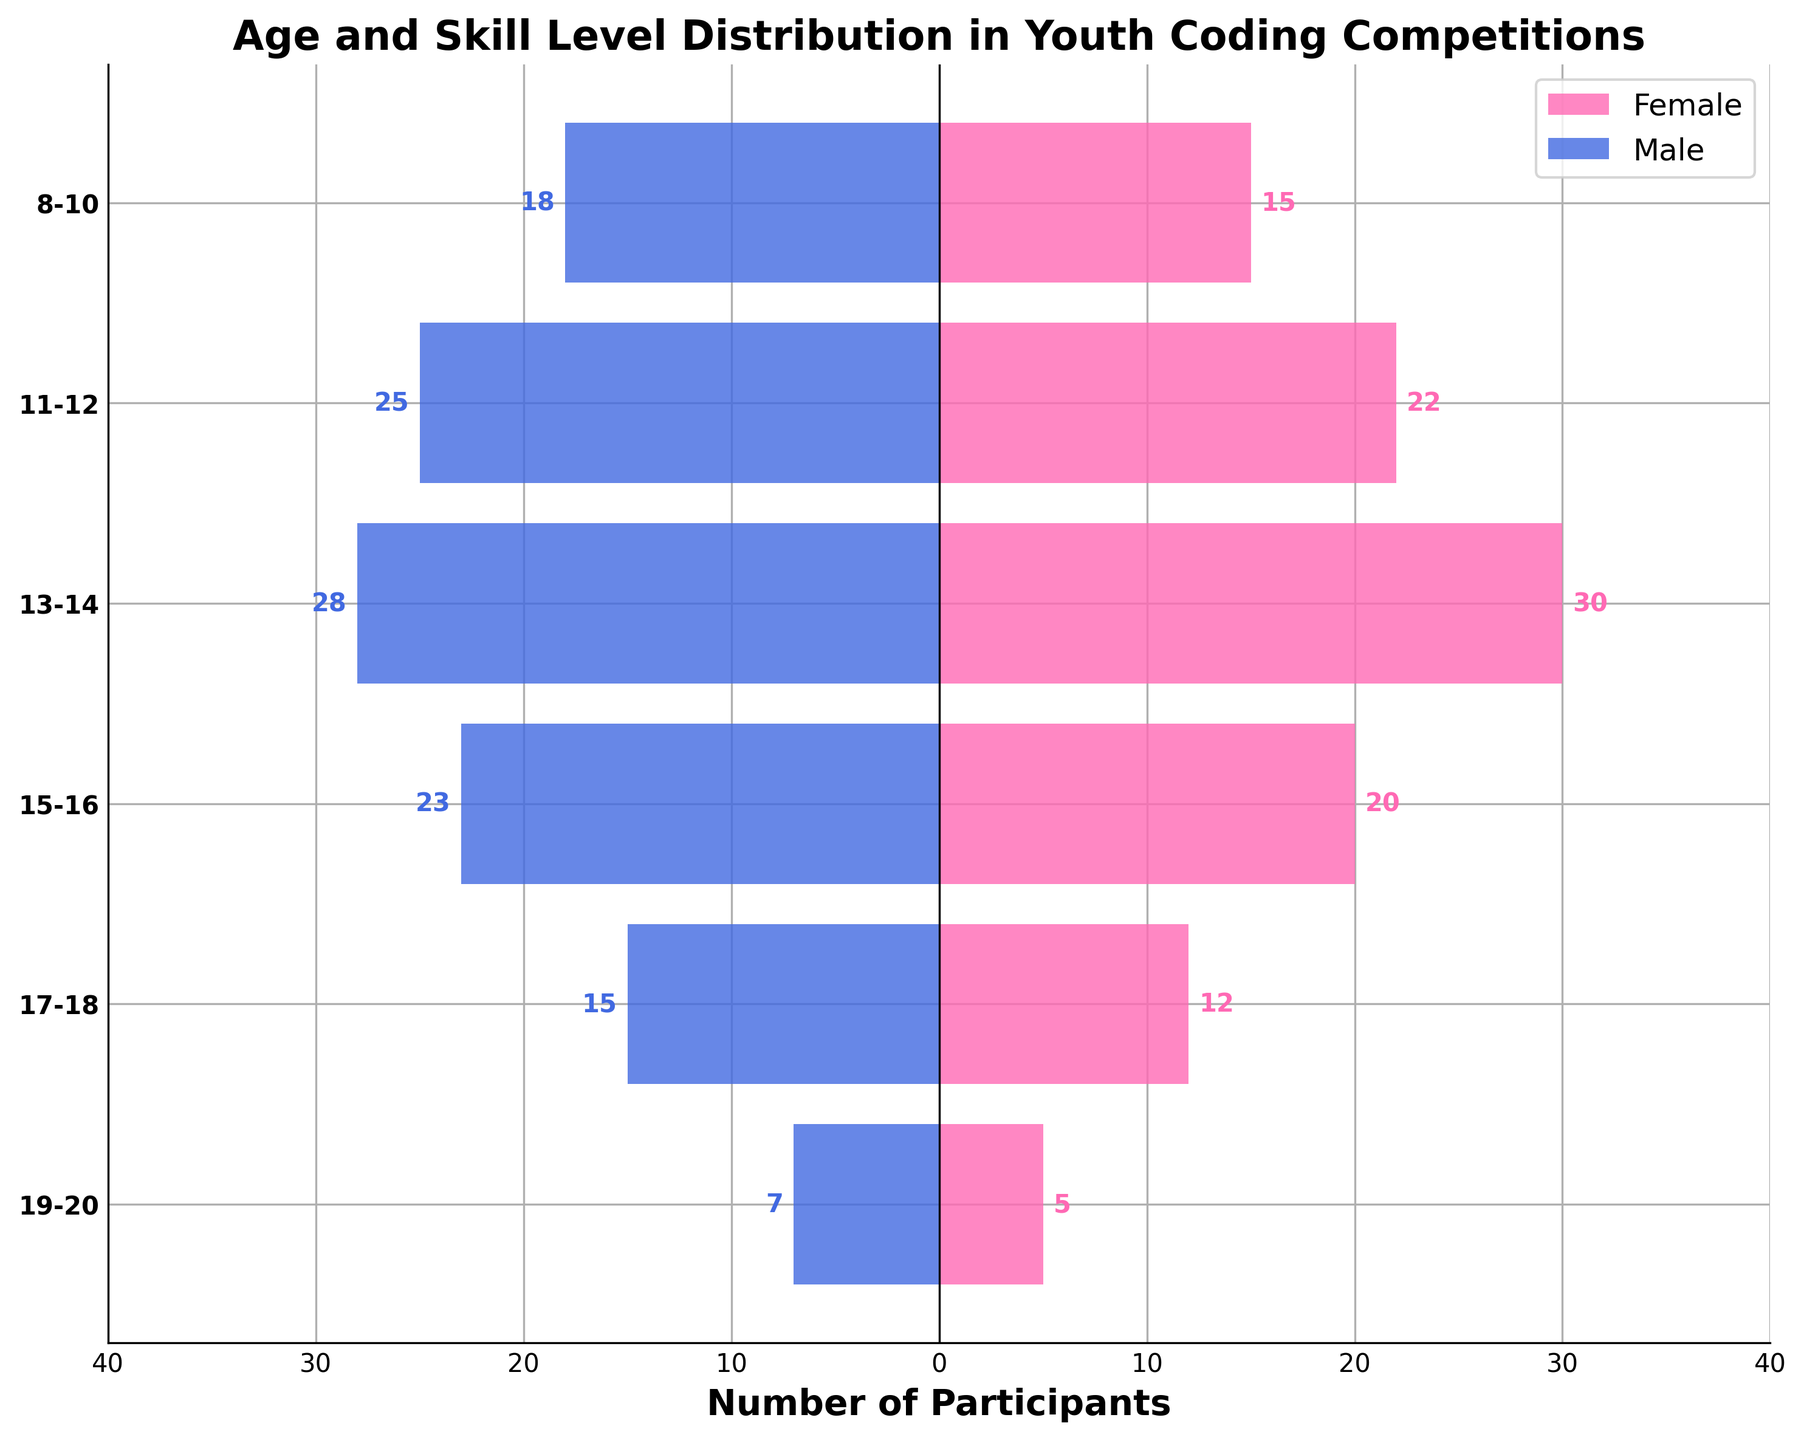What is the title of the plot? The title of the plot is usually displayed at the top. It says, "Age and Skill Level Distribution in Youth Coding Competitions."
Answer: Age and Skill Level Distribution in Youth Coding Competitions How many male participants are there in the 13-14 age group? The male bar for the 13-14 age group extends to -28. The negative sign indicates male participants.
Answer: 28 Which age group has the highest number of female participants? Compare the lengths of the pink bars representing female participants. The longest pink bar is for the 13-14 age group which is 30.
Answer: 13-14 What is the total number of participants in the 15-16 age group? Add the number of female and male participants for the 15-16 age group: 20 females + 23 males.
Answer: 43 How do the number of participants in the 8-10 age group compare between males and females? The male bar for the 8-10 age group is 18, and the female bar is 15. Compare 18 and 15.
Answer: More males What is the approximate range of the x-axis? The x-axis ranges from the highest negative value (leftmost of male bar) and highest positive value (rightmost of female bar). It covers from -30 to 30 approximately (since values around these are visible).
Answer: -30 to 30 Which gender has fewer participants in the 19-20 age group? Compare the length of the pink bar for females (5) and blue bar for males (7) in the 19-20 age group.
Answer: Female What is the total number of participants across all age groups? Sum up all male and female participants: (15+18) + (22+25) + (30+28) + (20+23) + (12+15) + (5+7) = 33 + 47 + 58 + 43 + 27 + 12 = 220
Answer: 220 Which age group has almost equal numbers of male and female participants? Compare the lengths of pink and blue bars for each age group. The 13-14 age group has 30 females and 28 males.
Answer: 13-14 